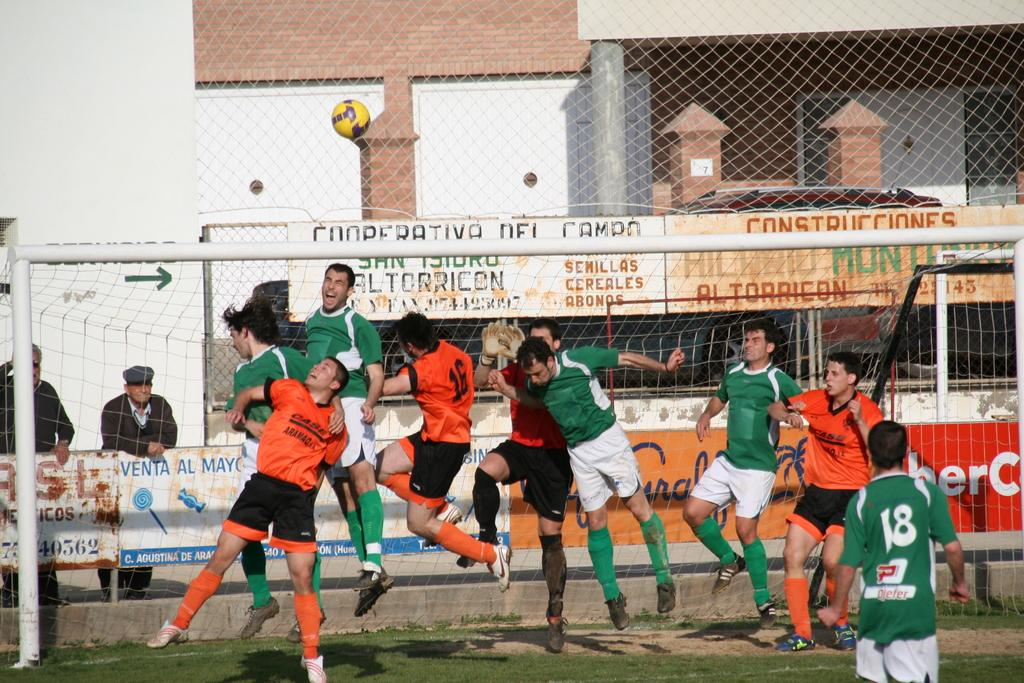<image>
Offer a succinct explanation of the picture presented. A man leans over a fence watching the soccer game, and the word venta is right below his hands. 